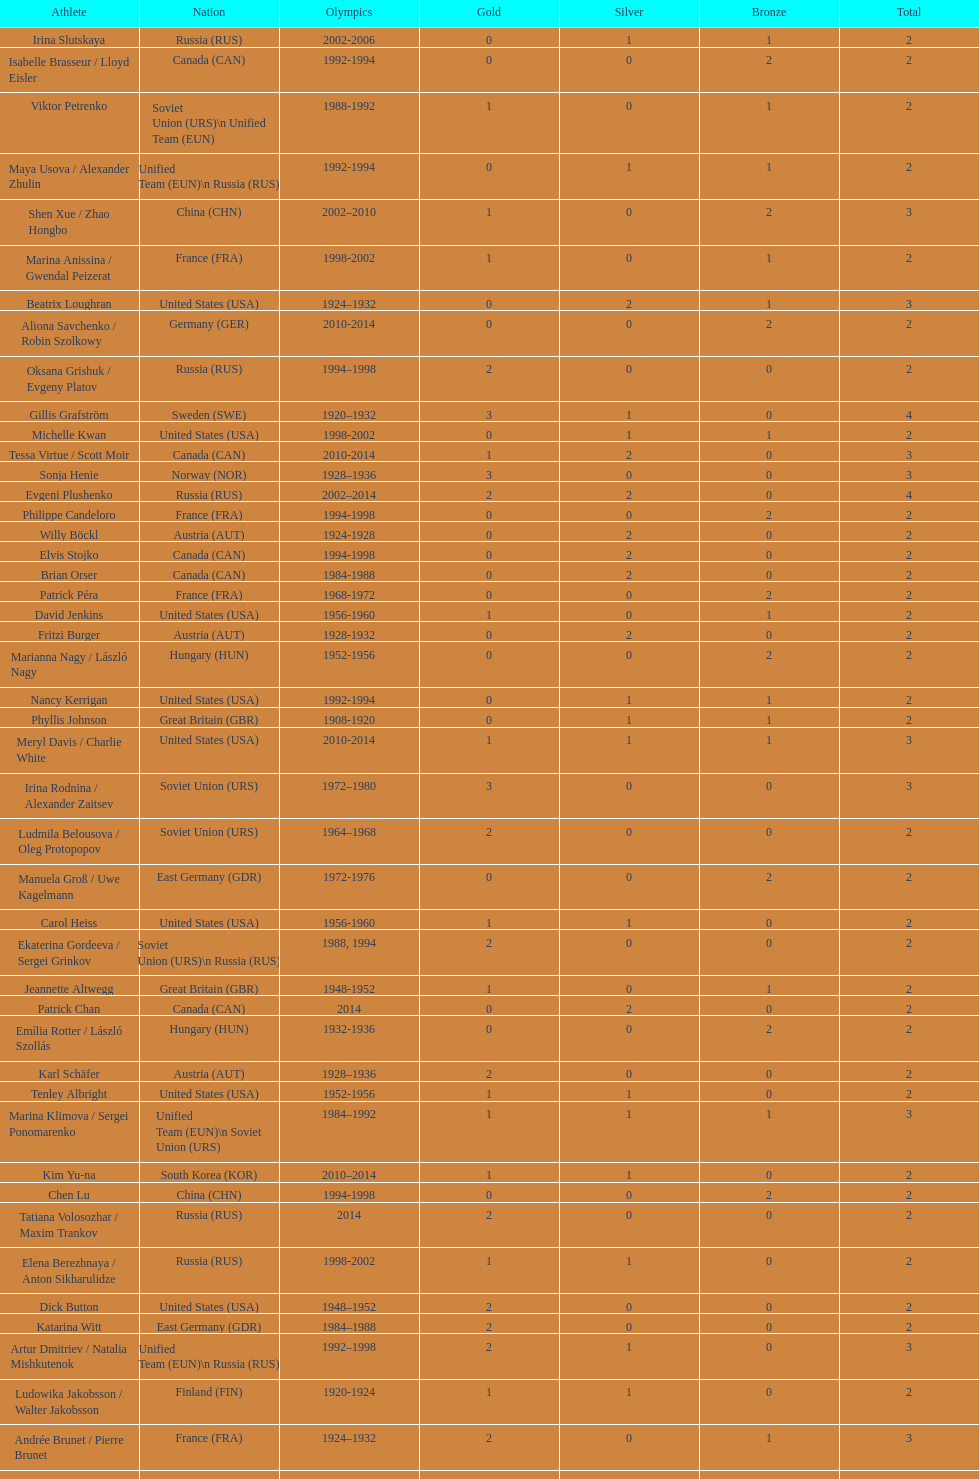How many silver medals did evgeni plushenko get? 2. 